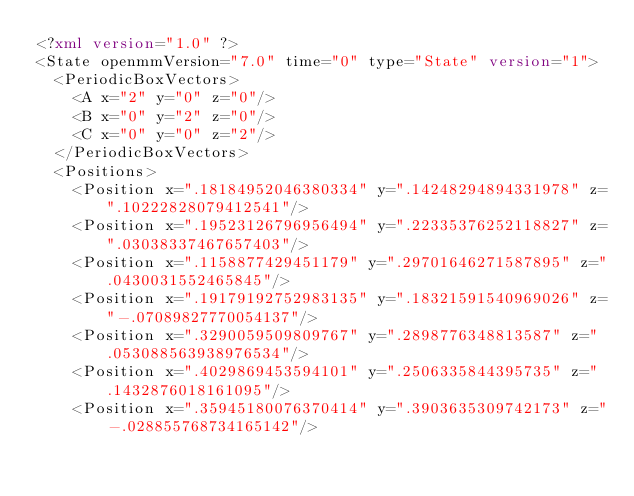Convert code to text. <code><loc_0><loc_0><loc_500><loc_500><_XML_><?xml version="1.0" ?>
<State openmmVersion="7.0" time="0" type="State" version="1">
	<PeriodicBoxVectors>
		<A x="2" y="0" z="0"/>
		<B x="0" y="2" z="0"/>
		<C x="0" y="0" z="2"/>
	</PeriodicBoxVectors>
	<Positions>
		<Position x=".18184952046380334" y=".14248294894331978" z=".10222828079412541"/>
		<Position x=".19523126796956494" y=".22335376252118827" z=".03038337467657403"/>
		<Position x=".1158877429451179" y=".29701646271587895" z=".0430031552465845"/>
		<Position x=".19179192752983135" y=".18321591540969026" z="-.07089827770054137"/>
		<Position x=".3290059509809767" y=".2898776348813587" z=".053088563938976534"/>
		<Position x=".4029869453594101" y=".2506335844395735" z=".1432876018161095"/>
		<Position x=".35945180076370414" y=".3903635309742173" z="-.028855768734165142"/></code> 